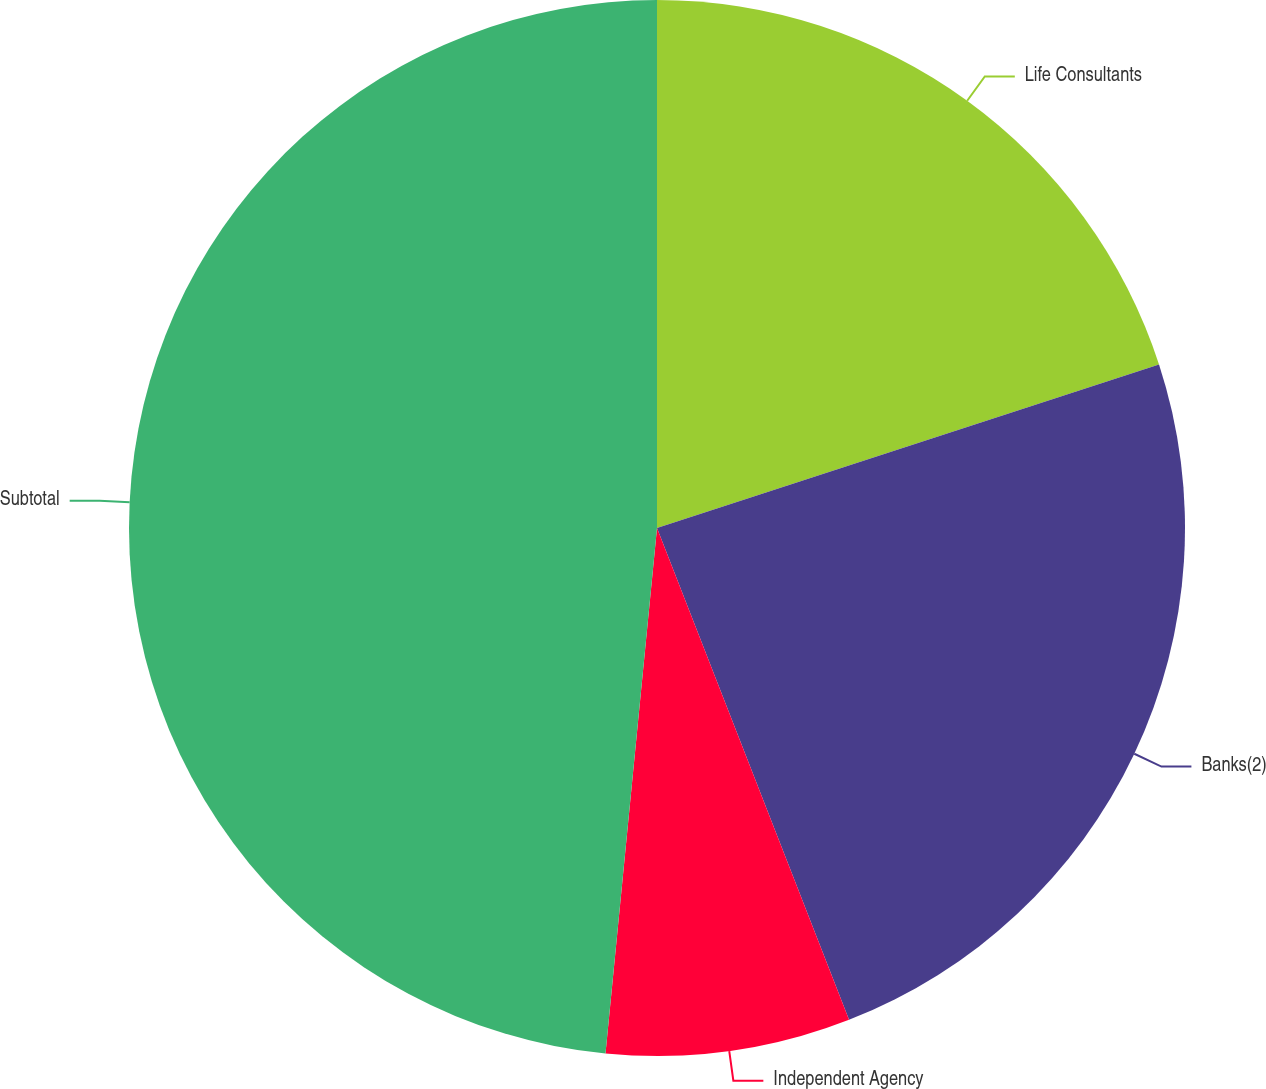Convert chart to OTSL. <chart><loc_0><loc_0><loc_500><loc_500><pie_chart><fcel>Life Consultants<fcel>Banks(2)<fcel>Independent Agency<fcel>Subtotal<nl><fcel>19.99%<fcel>24.09%<fcel>7.48%<fcel>48.45%<nl></chart> 